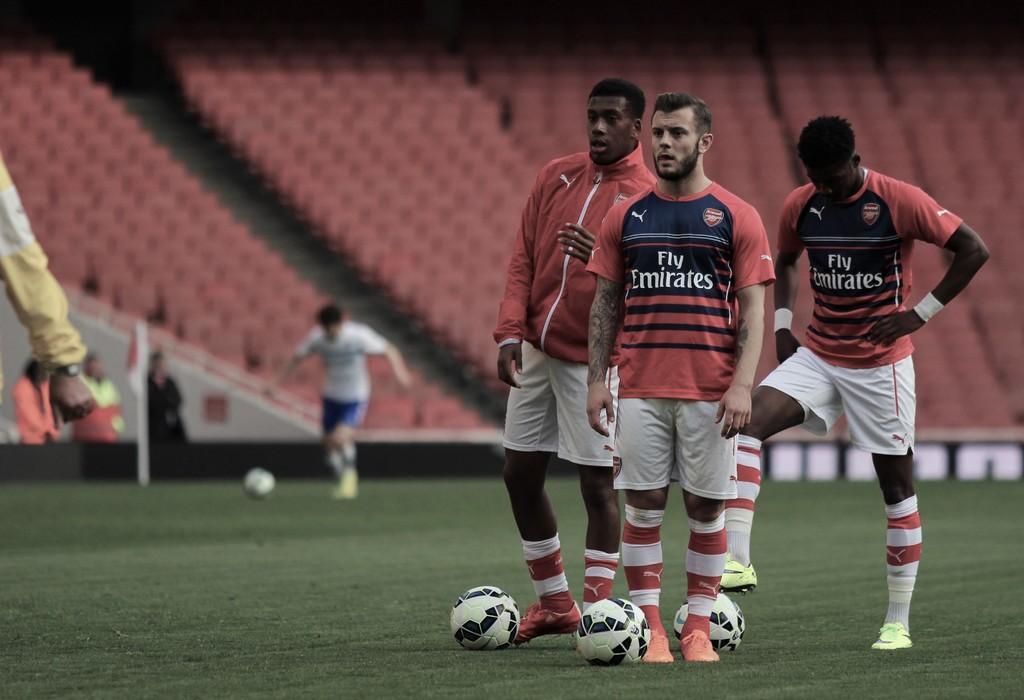Please provide a concise description of this image. In this picture we can see there are three people standing and another person is in motion. On the path there is are balls. Behind the people there is a pole, chairs and some people are standing. 